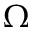<formula> <loc_0><loc_0><loc_500><loc_500>\Omega</formula> 